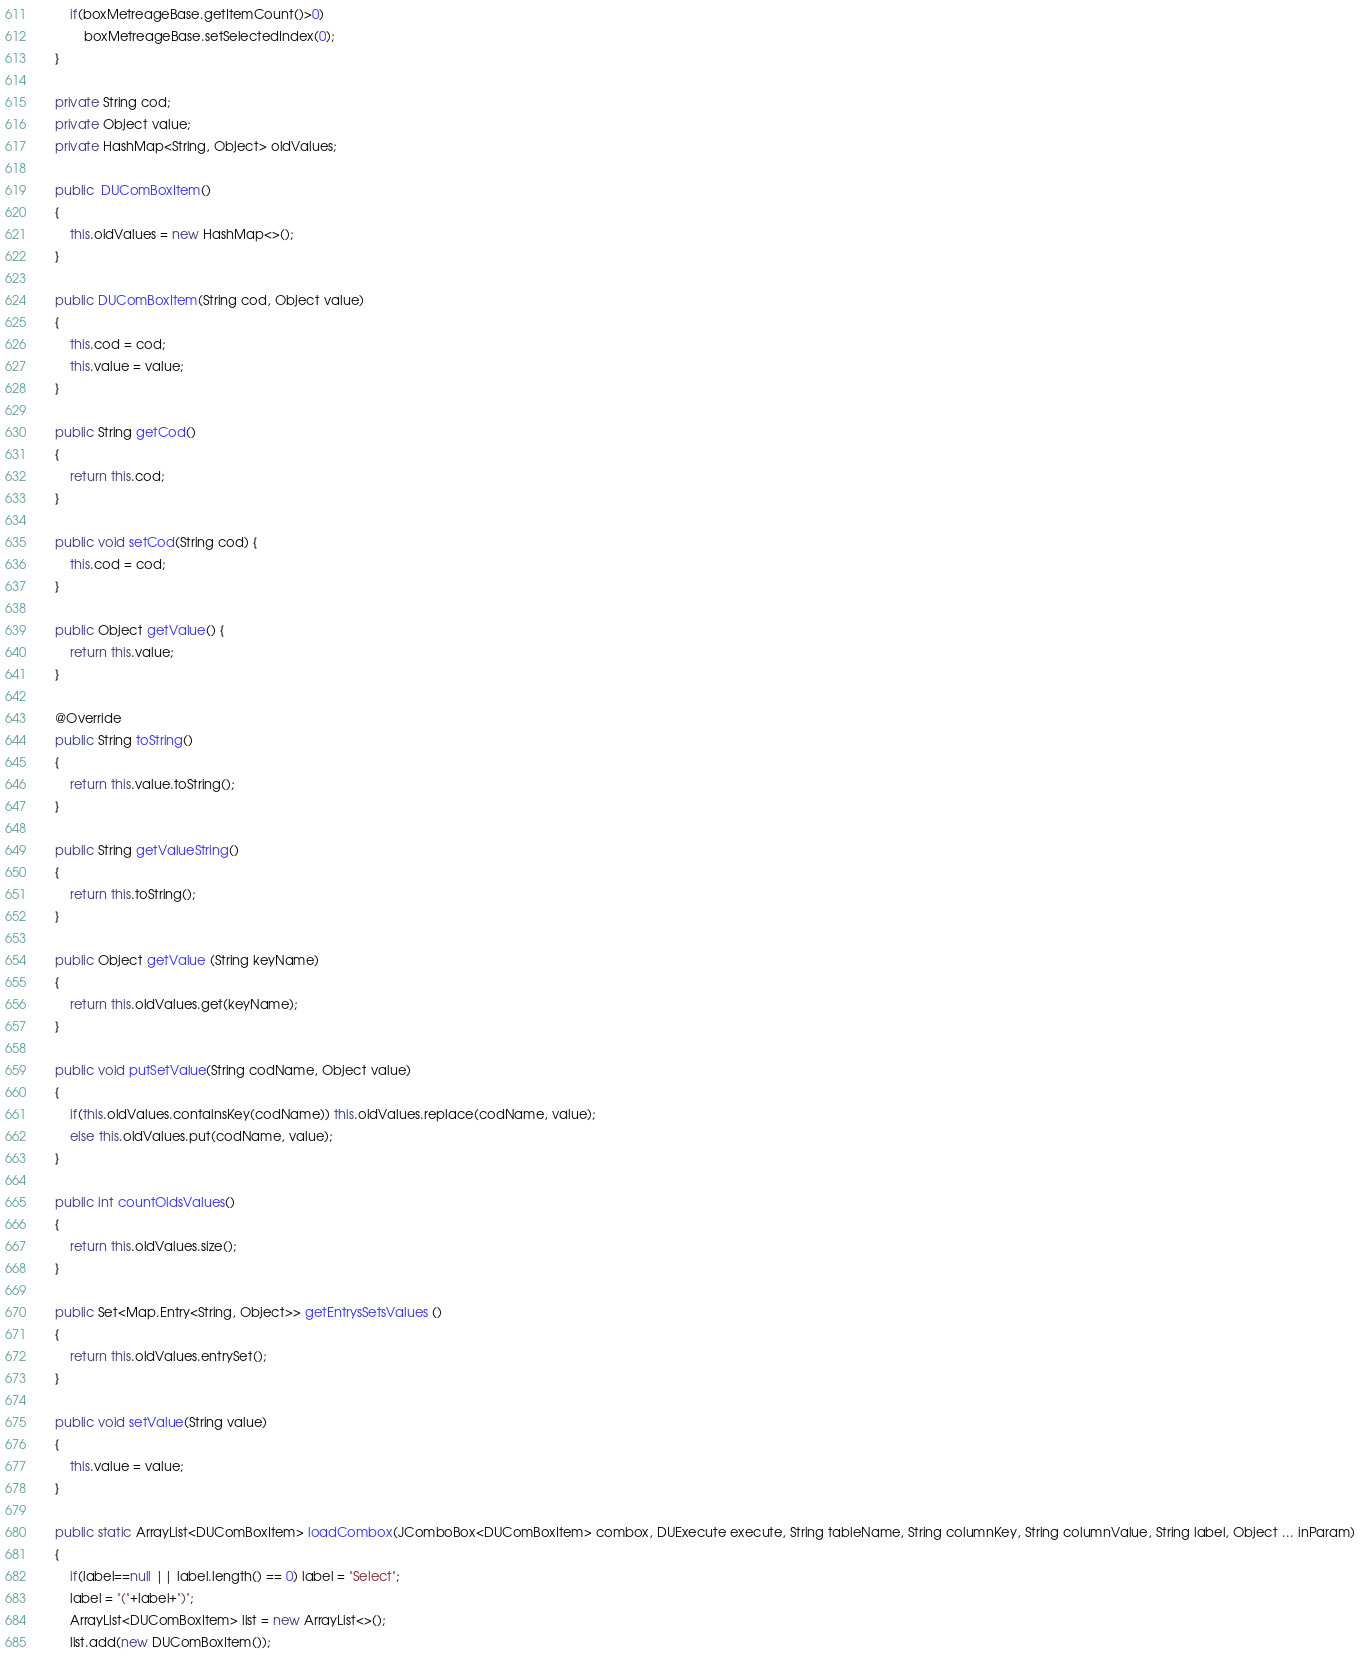<code> <loc_0><loc_0><loc_500><loc_500><_Java_>        if(boxMetreageBase.getItemCount()>0)
            boxMetreageBase.setSelectedIndex(0);
    }
    
    private String cod;
    private Object value;
    private HashMap<String, Object> oldValues;
    
    public  DUComBoxItem()
    {
        this.oldValues = new HashMap<>();
    }
    
    public DUComBoxItem(String cod, Object value)
    {
        this.cod = cod;
        this.value = value;
    }

    public String getCod()
    {
        return this.cod;
    }

    public void setCod(String cod) {
        this.cod = cod;
    }

    public Object getValue() {
        return this.value;
    }
    
    @Override
    public String toString()
    {
        return this.value.toString();
    }
    
    public String getValueString()
    {
        return this.toString();
    }
    
    public Object getValue (String keyName)
    {
        return this.oldValues.get(keyName);
    }
    
    public void putSetValue(String codName, Object value)
    {
        if(this.oldValues.containsKey(codName)) this.oldValues.replace(codName, value);
        else this.oldValues.put(codName, value);
    }
    
    public int countOldsValues()
    {
        return this.oldValues.size();
    }
    
    public Set<Map.Entry<String, Object>> getEntrysSetsValues ()
    {
        return this.oldValues.entrySet();
    }
    
    public void setValue(String value)
    {
        this.value = value;
    }
    
    public static ArrayList<DUComBoxItem> loadCombox(JComboBox<DUComBoxItem> combox, DUExecute execute, String tableName, String columnKey, String columnValue, String label, Object ... inParam)
    {
        if(label==null || label.length() == 0) label = "Select";
        label = "("+label+")";
        ArrayList<DUComBoxItem> list = new ArrayList<>();
        list.add(new DUComBoxItem());</code> 